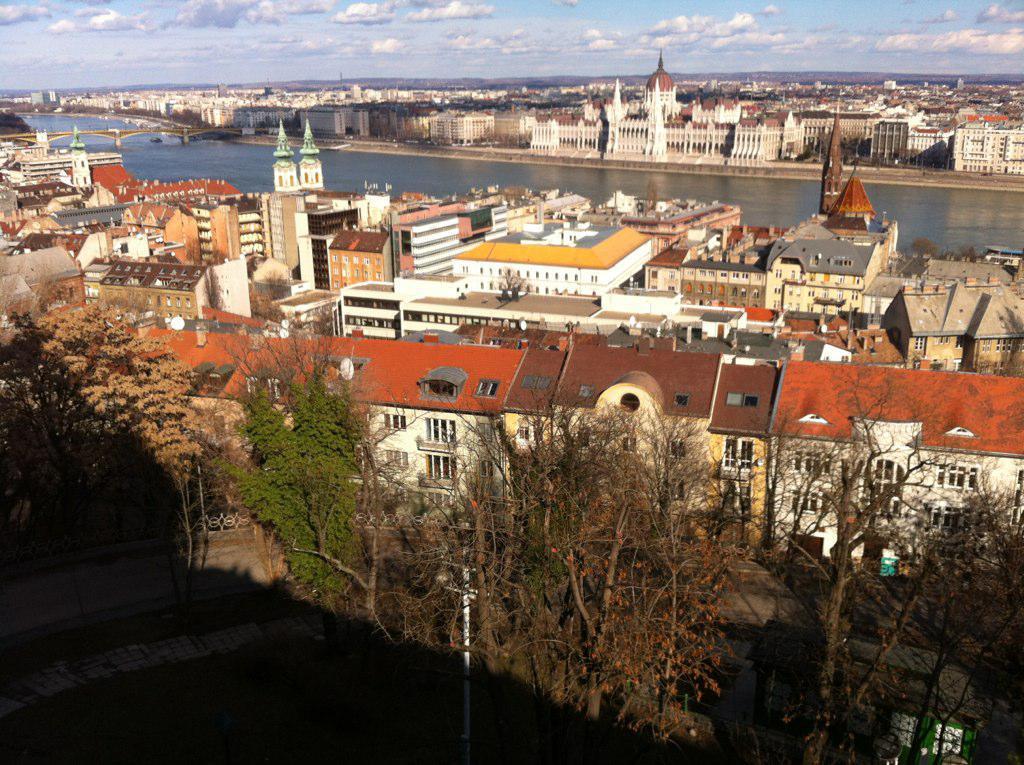Describe this image in one or two sentences. In this image I can see there are buildings and in between the buildings there is a water and a bridge. And there are trees and a grass. And there is a wall and a current poll. And at the top there is a cloudy sky. 